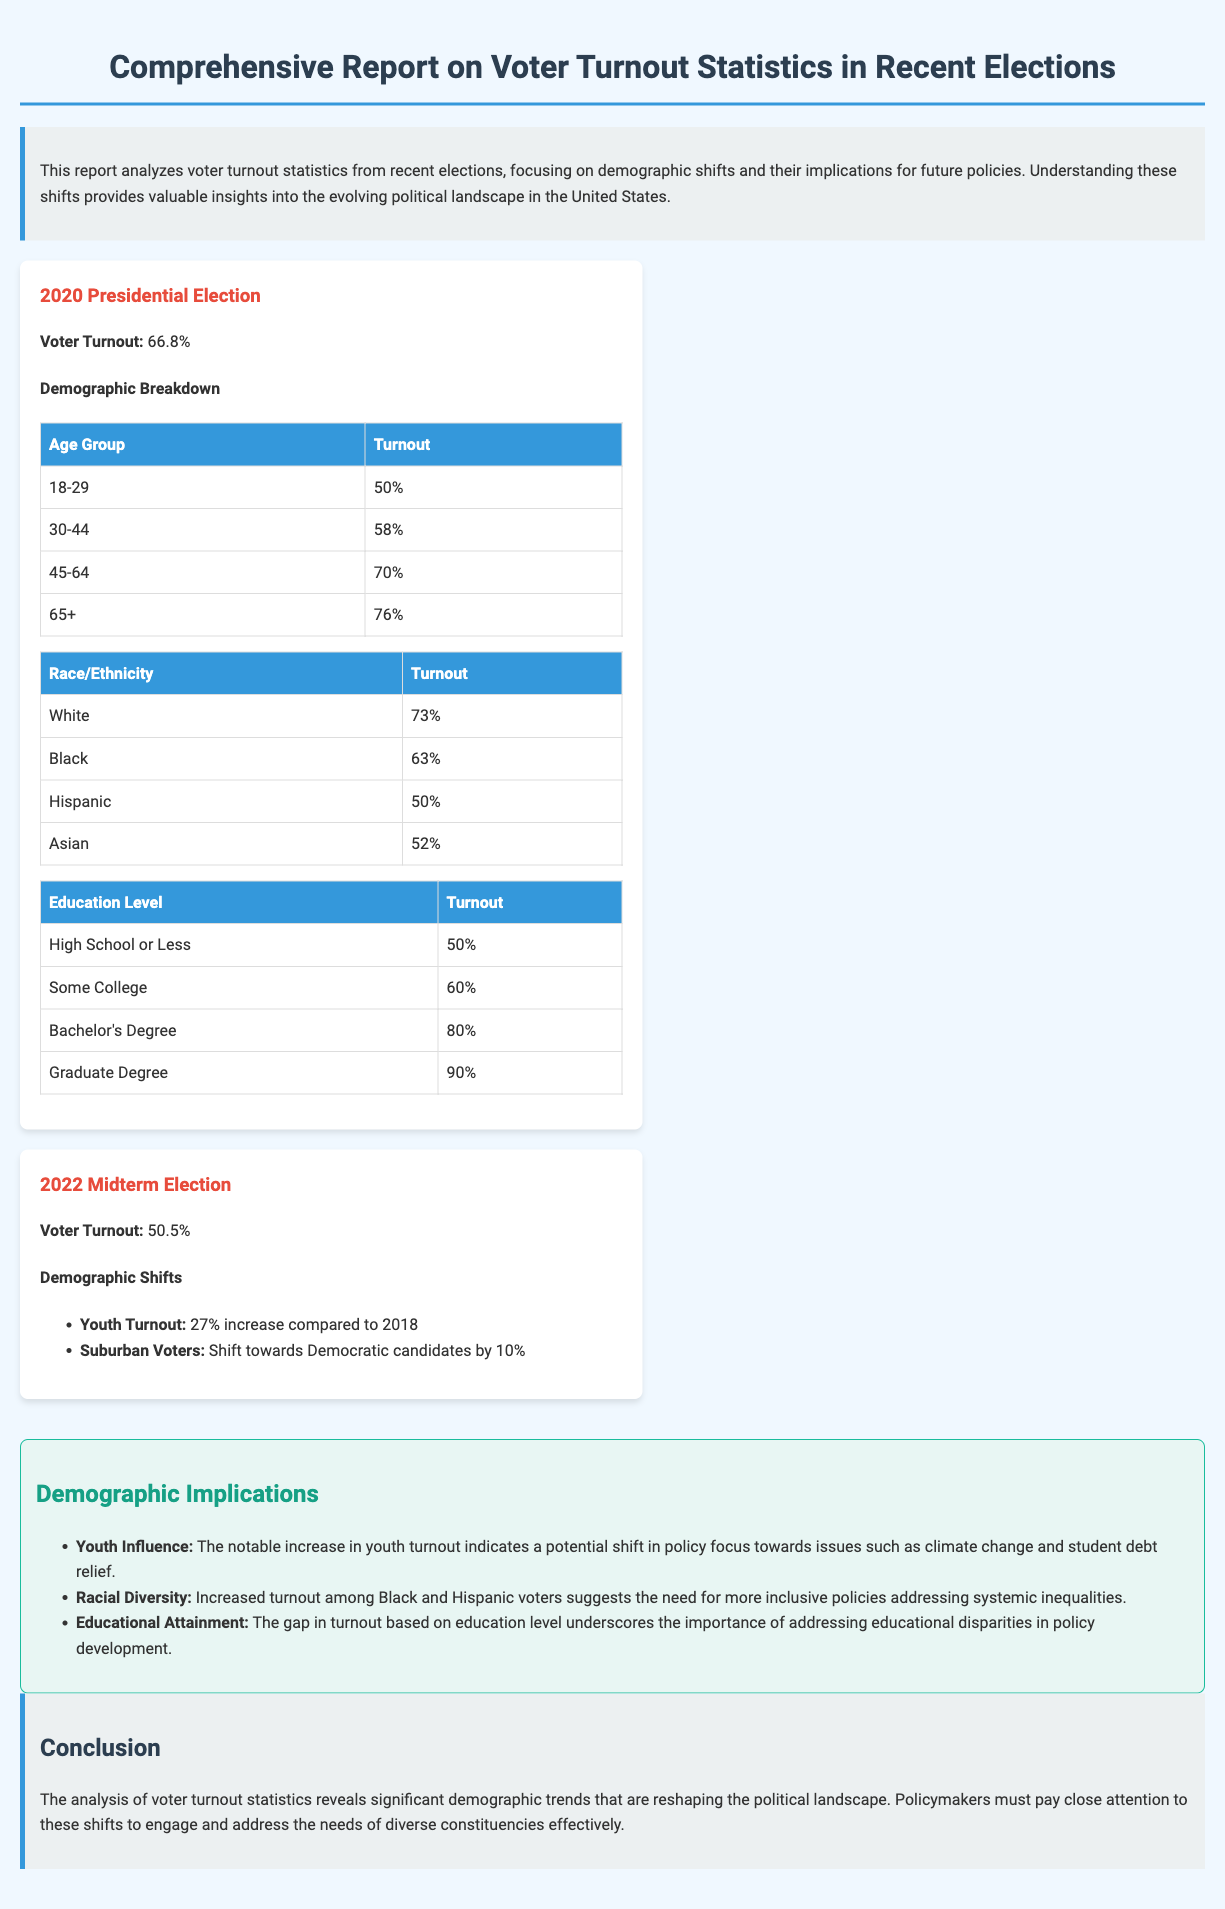What was the voter turnout for the 2020 Presidential Election? The document states that the voter turnout for the 2020 Presidential Election was 66.8%.
Answer: 66.8% What percentage of voters aged 18-29 turned out in the 2020 election? The document provides a breakdown that shows 50% of voters aged 18-29 participated in the 2020 election.
Answer: 50% What demographic saw a 27% increase in turnout in the 2022 Midterm Election compared to 2018? The document mentions that youth turnout increased by 27%.
Answer: Youth What was the voter turnout percentage for those with a Graduate Degree in the 2020 election? According to the document, the turnout for individuals with a Graduate Degree was 90%.
Answer: 90% What trend was observed regarding suburban voters in the 2022 Midterm Election? The document notes a shift towards Democratic candidates by 10% among suburban voters.
Answer: Shift towards Democratic What implication does the report suggest regarding the increase in Black and Hispanic voter turnout? The document states that it suggests the need for more inclusive policies addressing systemic inequalities.
Answer: More inclusive policies What was the voter turnout for the 2022 Midterm Election? The document records the voter turnout for the 2022 Midterm Election as 50.5%.
Answer: 50.5% What is the overall conclusion drawn from the analysis of voter turnout statistics? The conclusion states that significant demographic trends are reshaping the political landscape.
Answer: Significant demographic trends What demographic group is mentioned as having a notable influence on policy focus due to increased turnout? The document highlights that youth influence is significant due to their turnout increase.
Answer: Youth influence 